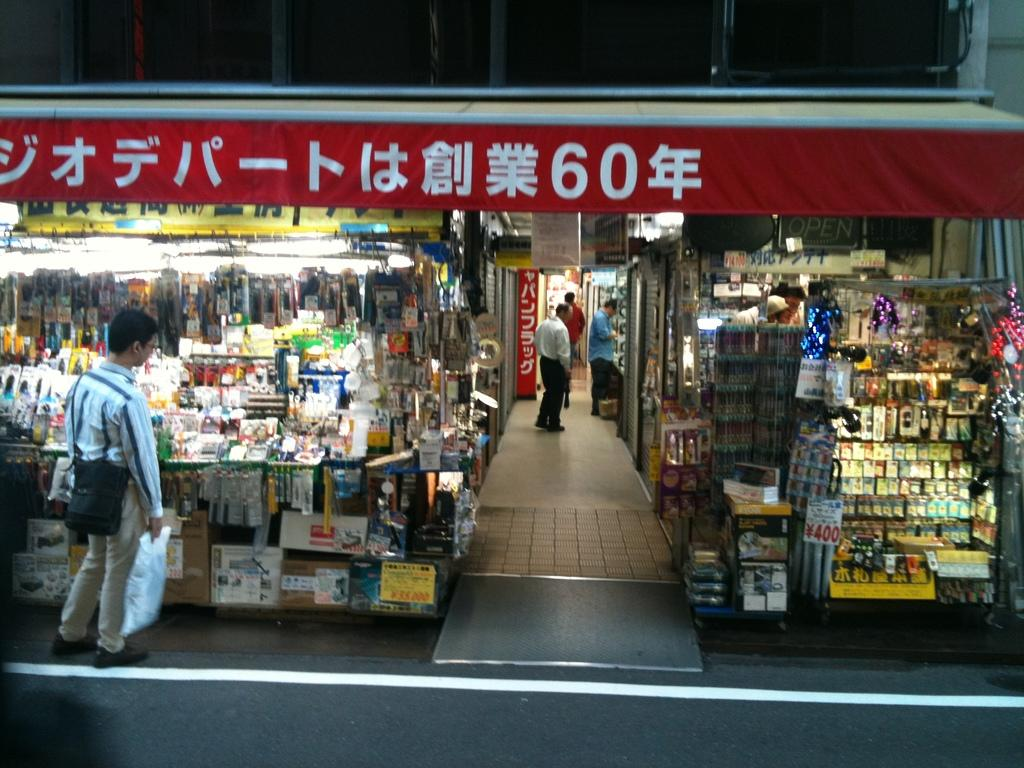<image>
Summarize the visual content of the image. A storefront with with Japanese characters. There are plenty of products on display and something priced at 400 yen. 